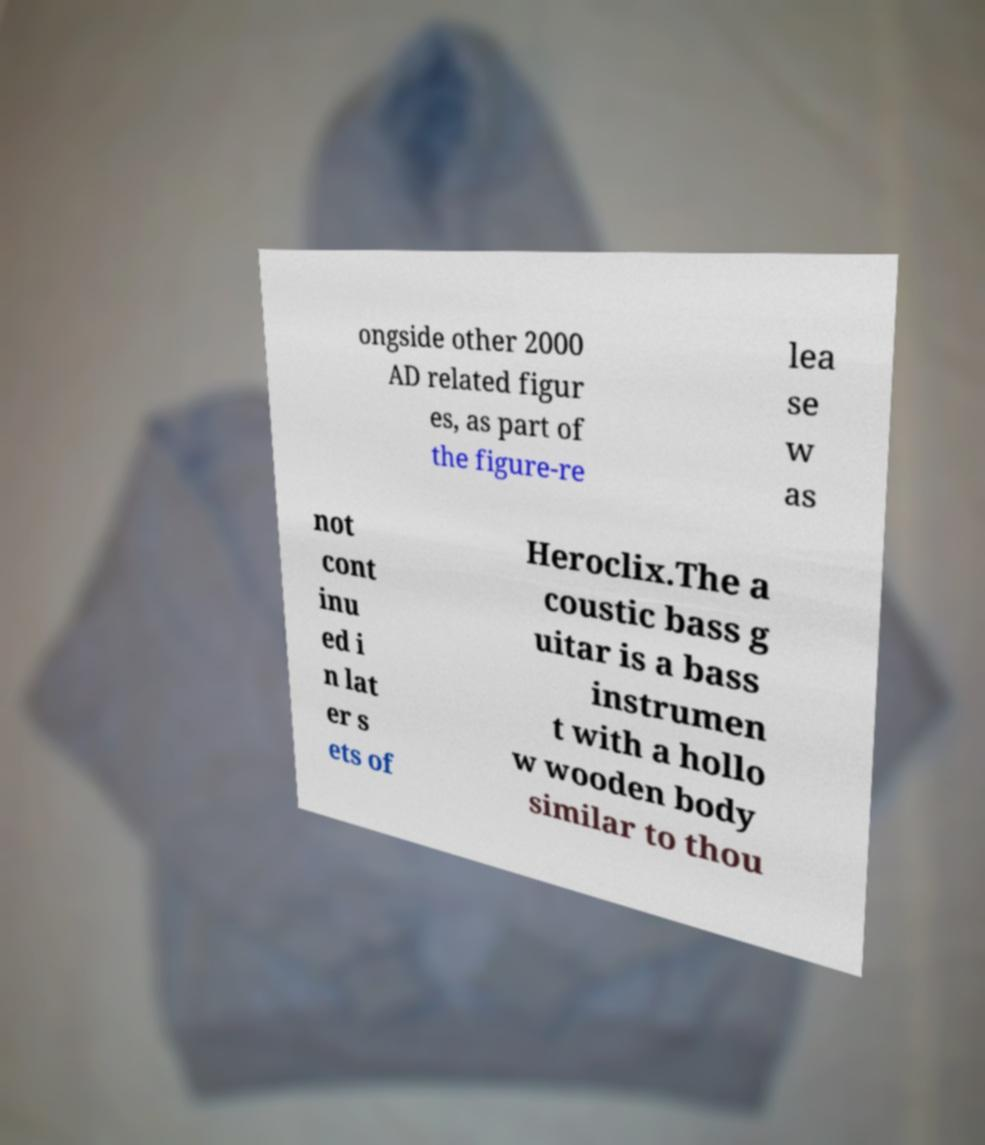I need the written content from this picture converted into text. Can you do that? ongside other 2000 AD related figur es, as part of the figure-re lea se w as not cont inu ed i n lat er s ets of Heroclix.The a coustic bass g uitar is a bass instrumen t with a hollo w wooden body similar to thou 